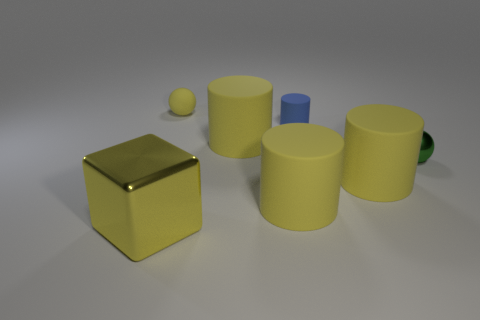What is the size of the cylinder that is to the left of the blue object and behind the green ball?
Provide a short and direct response. Large. What number of red cylinders are the same size as the green object?
Your answer should be very brief. 0. What number of large cylinders are in front of the tiny sphere that is to the right of the tiny yellow rubber sphere?
Your answer should be very brief. 2. There is a small sphere that is behind the tiny green metallic thing; does it have the same color as the metallic sphere?
Make the answer very short. No. Are there any shiny spheres left of the matte object left of the big yellow object behind the metallic sphere?
Give a very brief answer. No. Are there any big cylinders of the same color as the big cube?
Your answer should be compact. Yes. There is a sphere that is right of the tiny rubber thing that is on the right side of the small yellow object; what color is it?
Your answer should be very brief. Green. How big is the sphere left of the tiny blue rubber cylinder to the left of the metallic object that is to the right of the yellow ball?
Your response must be concise. Small. Does the small blue object have the same material as the yellow thing right of the blue cylinder?
Offer a very short reply. Yes. There is a ball that is the same material as the yellow cube; what is its size?
Ensure brevity in your answer.  Small. 